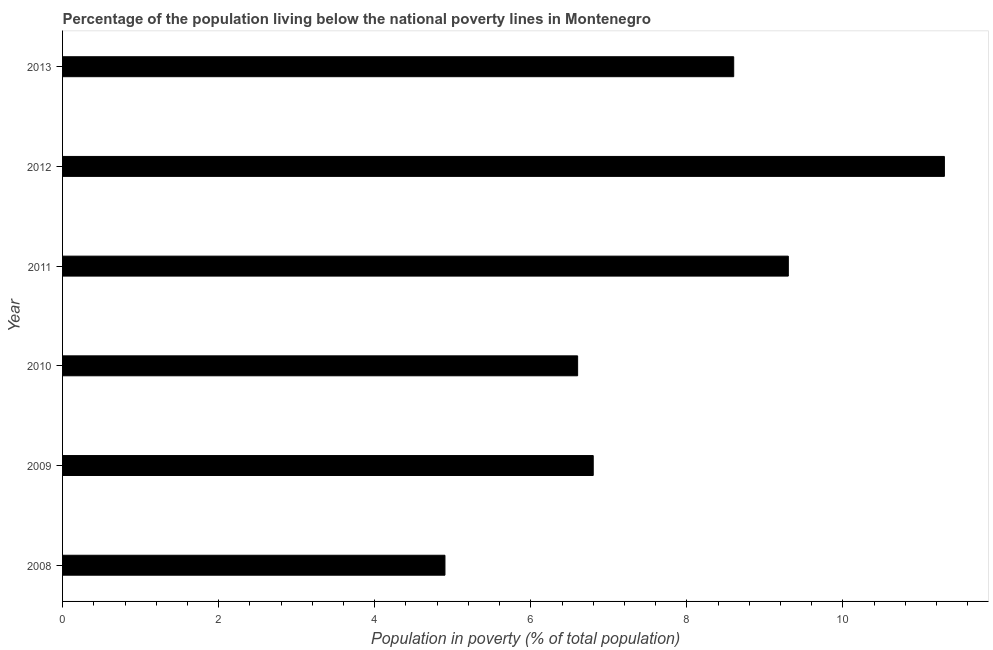Does the graph contain any zero values?
Keep it short and to the point. No. Does the graph contain grids?
Offer a very short reply. No. What is the title of the graph?
Your answer should be compact. Percentage of the population living below the national poverty lines in Montenegro. What is the label or title of the X-axis?
Your answer should be very brief. Population in poverty (% of total population). What is the sum of the percentage of population living below poverty line?
Give a very brief answer. 47.5. What is the average percentage of population living below poverty line per year?
Keep it short and to the point. 7.92. What is the median percentage of population living below poverty line?
Offer a terse response. 7.7. In how many years, is the percentage of population living below poverty line greater than 9.2 %?
Offer a very short reply. 2. Do a majority of the years between 2008 and 2009 (inclusive) have percentage of population living below poverty line greater than 8 %?
Offer a very short reply. No. What is the ratio of the percentage of population living below poverty line in 2008 to that in 2013?
Your response must be concise. 0.57. Is the percentage of population living below poverty line in 2009 less than that in 2013?
Provide a short and direct response. Yes. What is the difference between the highest and the lowest percentage of population living below poverty line?
Make the answer very short. 6.4. In how many years, is the percentage of population living below poverty line greater than the average percentage of population living below poverty line taken over all years?
Your answer should be compact. 3. How many bars are there?
Your answer should be very brief. 6. How many years are there in the graph?
Keep it short and to the point. 6. What is the Population in poverty (% of total population) of 2012?
Ensure brevity in your answer.  11.3. What is the Population in poverty (% of total population) of 2013?
Your response must be concise. 8.6. What is the difference between the Population in poverty (% of total population) in 2008 and 2010?
Offer a terse response. -1.7. What is the difference between the Population in poverty (% of total population) in 2008 and 2013?
Ensure brevity in your answer.  -3.7. What is the difference between the Population in poverty (% of total population) in 2009 and 2012?
Keep it short and to the point. -4.5. What is the difference between the Population in poverty (% of total population) in 2010 and 2011?
Your answer should be compact. -2.7. What is the difference between the Population in poverty (% of total population) in 2010 and 2012?
Give a very brief answer. -4.7. What is the difference between the Population in poverty (% of total population) in 2011 and 2013?
Give a very brief answer. 0.7. What is the difference between the Population in poverty (% of total population) in 2012 and 2013?
Your answer should be compact. 2.7. What is the ratio of the Population in poverty (% of total population) in 2008 to that in 2009?
Your response must be concise. 0.72. What is the ratio of the Population in poverty (% of total population) in 2008 to that in 2010?
Ensure brevity in your answer.  0.74. What is the ratio of the Population in poverty (% of total population) in 2008 to that in 2011?
Your response must be concise. 0.53. What is the ratio of the Population in poverty (% of total population) in 2008 to that in 2012?
Ensure brevity in your answer.  0.43. What is the ratio of the Population in poverty (% of total population) in 2008 to that in 2013?
Keep it short and to the point. 0.57. What is the ratio of the Population in poverty (% of total population) in 2009 to that in 2011?
Your answer should be compact. 0.73. What is the ratio of the Population in poverty (% of total population) in 2009 to that in 2012?
Your answer should be very brief. 0.6. What is the ratio of the Population in poverty (% of total population) in 2009 to that in 2013?
Give a very brief answer. 0.79. What is the ratio of the Population in poverty (% of total population) in 2010 to that in 2011?
Provide a short and direct response. 0.71. What is the ratio of the Population in poverty (% of total population) in 2010 to that in 2012?
Your answer should be compact. 0.58. What is the ratio of the Population in poverty (% of total population) in 2010 to that in 2013?
Ensure brevity in your answer.  0.77. What is the ratio of the Population in poverty (% of total population) in 2011 to that in 2012?
Provide a short and direct response. 0.82. What is the ratio of the Population in poverty (% of total population) in 2011 to that in 2013?
Ensure brevity in your answer.  1.08. What is the ratio of the Population in poverty (% of total population) in 2012 to that in 2013?
Your answer should be very brief. 1.31. 